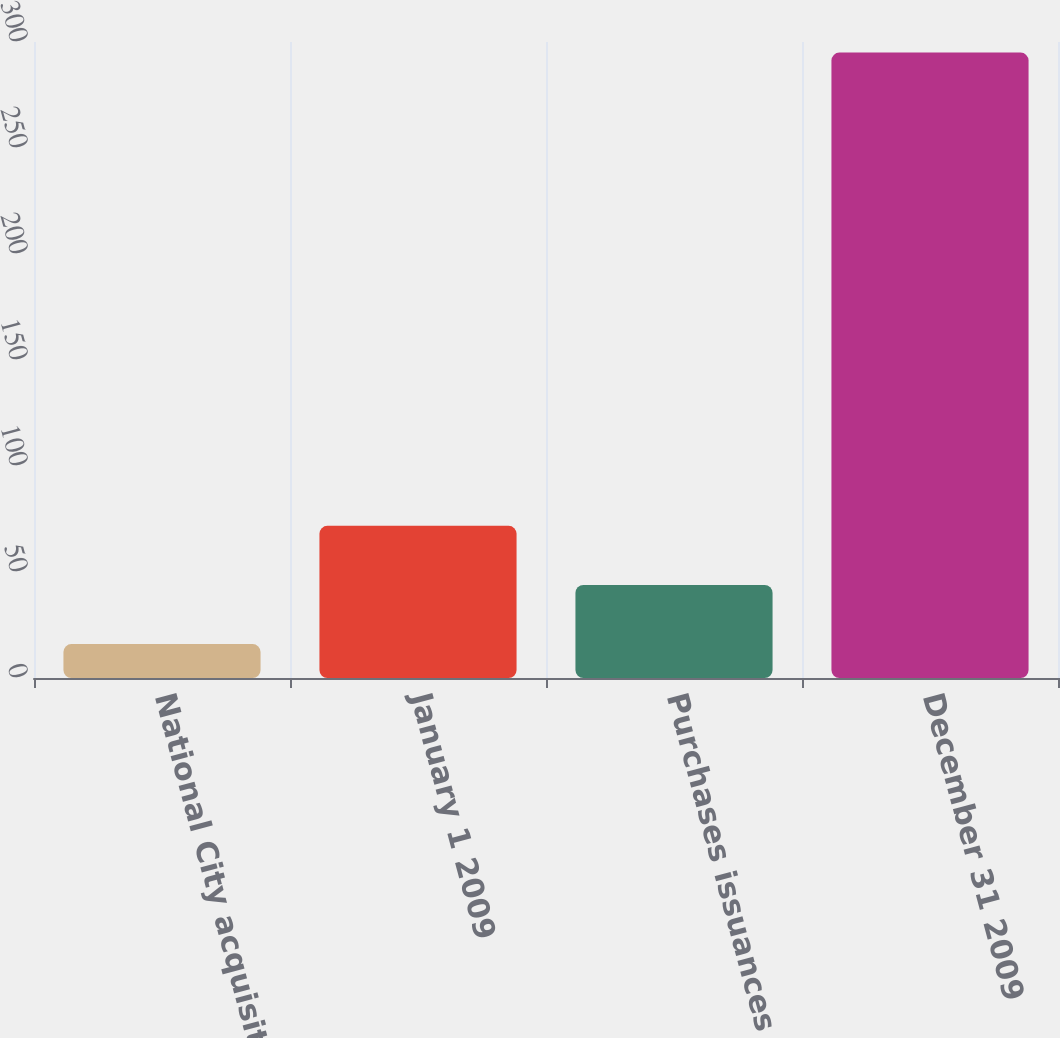Convert chart to OTSL. <chart><loc_0><loc_0><loc_500><loc_500><bar_chart><fcel>National City acquisition<fcel>January 1 2009<fcel>Purchases issuances and<fcel>December 31 2009<nl><fcel>16<fcel>71.8<fcel>43.9<fcel>295<nl></chart> 